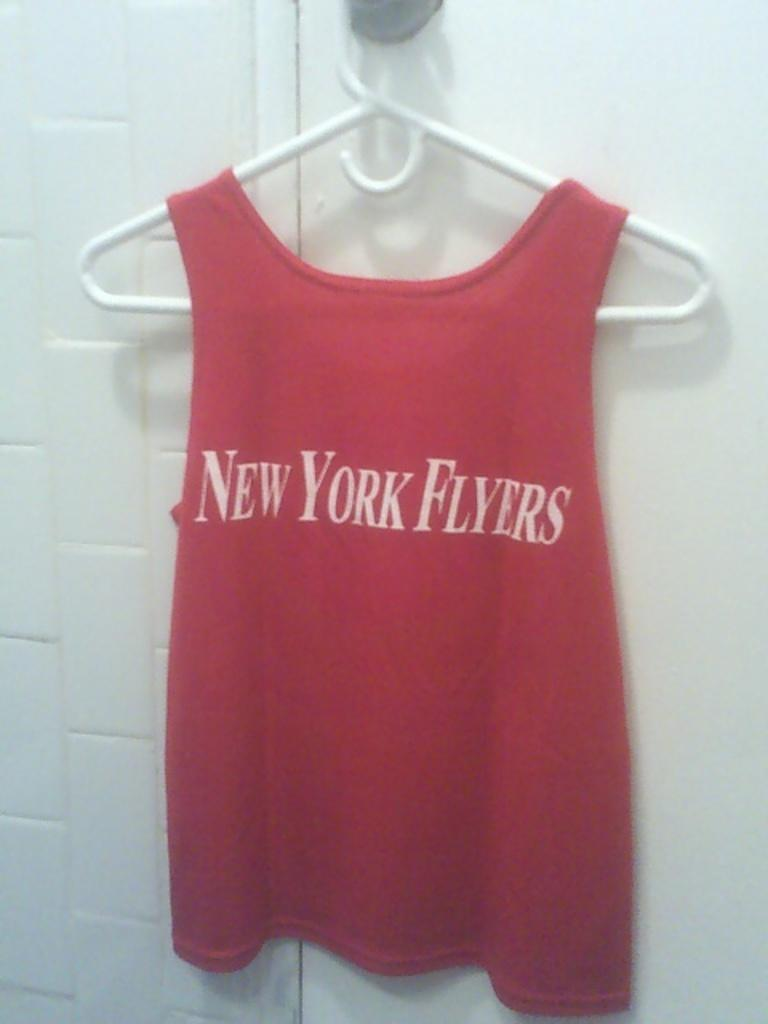What is hanging on the hanger in the image? There is a red dress on a hanger in the image. What is written on the red dress? The name "New York Flyers" is written on the dress. What can be seen in the background of the image? There is a white wall in the background of the image. Can you see any animals from the zoo in the image? There are no animals from the zoo present in the image. How many times does the stranger sneeze in the image? There is no stranger present in the image, so it is not possible to determine how many times they sneeze. 